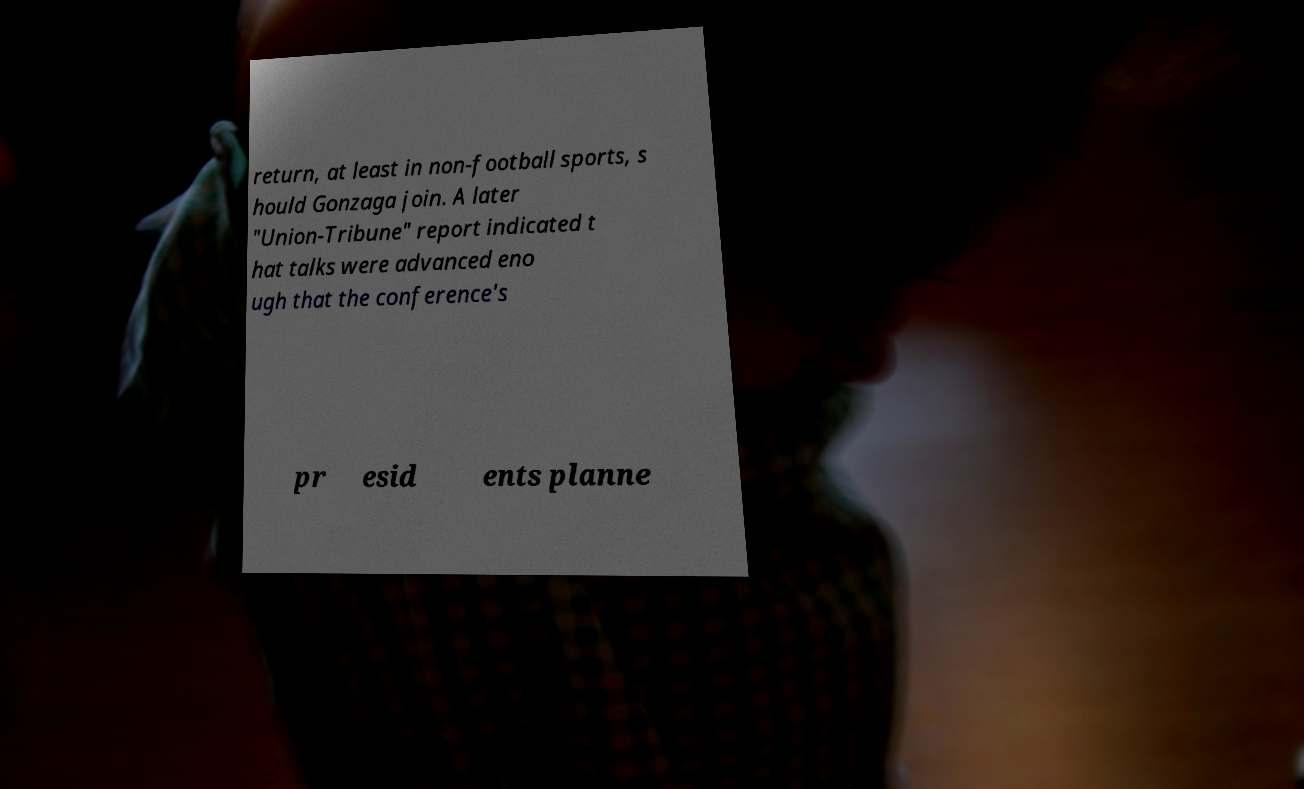Please read and relay the text visible in this image. What does it say? return, at least in non-football sports, s hould Gonzaga join. A later "Union-Tribune" report indicated t hat talks were advanced eno ugh that the conference's pr esid ents planne 